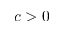Convert formula to latex. <formula><loc_0><loc_0><loc_500><loc_500>c > 0</formula> 